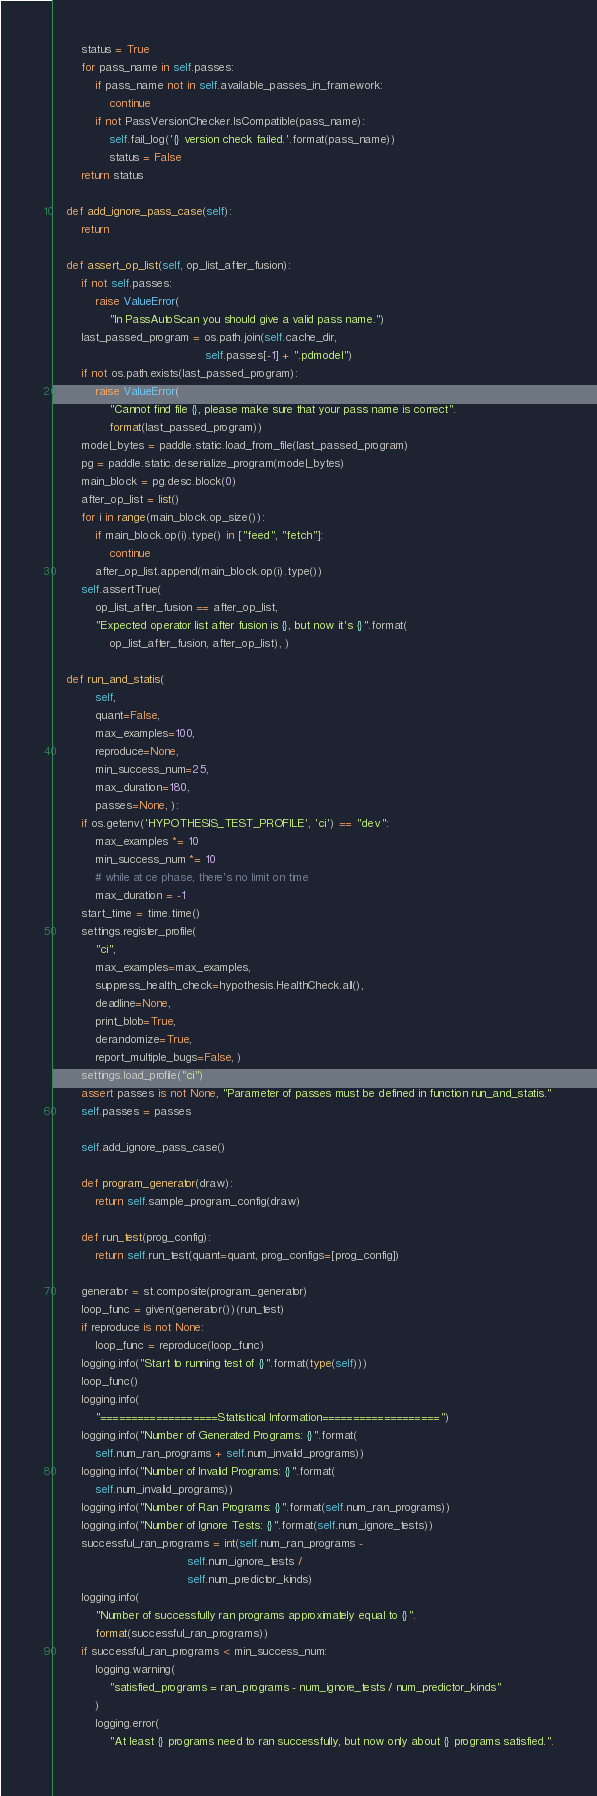Convert code to text. <code><loc_0><loc_0><loc_500><loc_500><_Python_>        status = True
        for pass_name in self.passes:
            if pass_name not in self.available_passes_in_framework:
                continue
            if not PassVersionChecker.IsCompatible(pass_name):
                self.fail_log('{} version check failed.'.format(pass_name))
                status = False
        return status

    def add_ignore_pass_case(self):
        return

    def assert_op_list(self, op_list_after_fusion):
        if not self.passes:
            raise ValueError(
                "In PassAutoScan you should give a valid pass name.")
        last_passed_program = os.path.join(self.cache_dir,
                                           self.passes[-1] + ".pdmodel")
        if not os.path.exists(last_passed_program):
            raise ValueError(
                "Cannot find file {}, please make sure that your pass name is correct".
                format(last_passed_program))
        model_bytes = paddle.static.load_from_file(last_passed_program)
        pg = paddle.static.deserialize_program(model_bytes)
        main_block = pg.desc.block(0)
        after_op_list = list()
        for i in range(main_block.op_size()):
            if main_block.op(i).type() in ["feed", "fetch"]:
                continue
            after_op_list.append(main_block.op(i).type())
        self.assertTrue(
            op_list_after_fusion == after_op_list,
            "Expected operator list after fusion is {}, but now it's {}".format(
                op_list_after_fusion, after_op_list), )

    def run_and_statis(
            self,
            quant=False,
            max_examples=100,
            reproduce=None,
            min_success_num=25,
            max_duration=180,
            passes=None, ):
        if os.getenv('HYPOTHESIS_TEST_PROFILE', 'ci') == "dev":
            max_examples *= 10
            min_success_num *= 10
            # while at ce phase, there's no limit on time
            max_duration = -1
        start_time = time.time()
        settings.register_profile(
            "ci",
            max_examples=max_examples,
            suppress_health_check=hypothesis.HealthCheck.all(),
            deadline=None,
            print_blob=True,
            derandomize=True,
            report_multiple_bugs=False, )
        settings.load_profile("ci")
        assert passes is not None, "Parameter of passes must be defined in function run_and_statis."
        self.passes = passes

        self.add_ignore_pass_case()

        def program_generator(draw):
            return self.sample_program_config(draw)

        def run_test(prog_config):
            return self.run_test(quant=quant, prog_configs=[prog_config])

        generator = st.composite(program_generator)
        loop_func = given(generator())(run_test)
        if reproduce is not None:
            loop_func = reproduce(loop_func)
        logging.info("Start to running test of {}".format(type(self)))
        loop_func()
        logging.info(
            "===================Statistical Information===================")
        logging.info("Number of Generated Programs: {}".format(
            self.num_ran_programs + self.num_invalid_programs))
        logging.info("Number of Invalid Programs: {}".format(
            self.num_invalid_programs))
        logging.info("Number of Ran Programs: {}".format(self.num_ran_programs))
        logging.info("Number of Ignore Tests: {}".format(self.num_ignore_tests))
        successful_ran_programs = int(self.num_ran_programs -
                                      self.num_ignore_tests /
                                      self.num_predictor_kinds)
        logging.info(
            "Number of successfully ran programs approximately equal to {}".
            format(successful_ran_programs))
        if successful_ran_programs < min_success_num:
            logging.warning(
                "satisfied_programs = ran_programs - num_ignore_tests / num_predictor_kinds"
            )
            logging.error(
                "At least {} programs need to ran successfully, but now only about {} programs satisfied.".</code> 